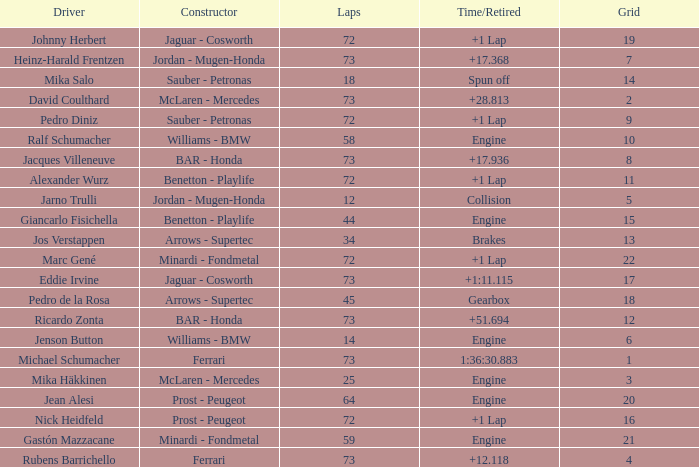How many laps did Giancarlo Fisichella do with a grid larger than 15? 0.0. 